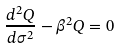Convert formula to latex. <formula><loc_0><loc_0><loc_500><loc_500>\frac { d ^ { 2 } Q } { d \sigma ^ { 2 } } - \beta ^ { 2 } Q = 0</formula> 